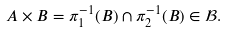<formula> <loc_0><loc_0><loc_500><loc_500>A \times B = \pi _ { 1 } ^ { - 1 } ( B ) \cap \pi _ { 2 } ^ { - 1 } ( B ) \in \mathcal { B } .</formula> 